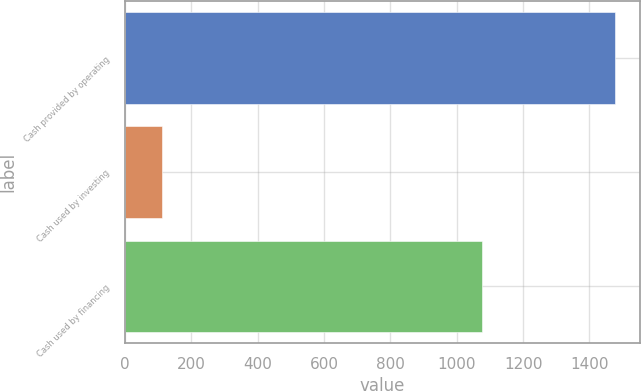Convert chart. <chart><loc_0><loc_0><loc_500><loc_500><bar_chart><fcel>Cash provided by operating<fcel>Cash used by investing<fcel>Cash used by financing<nl><fcel>1477.9<fcel>112.4<fcel>1076.9<nl></chart> 